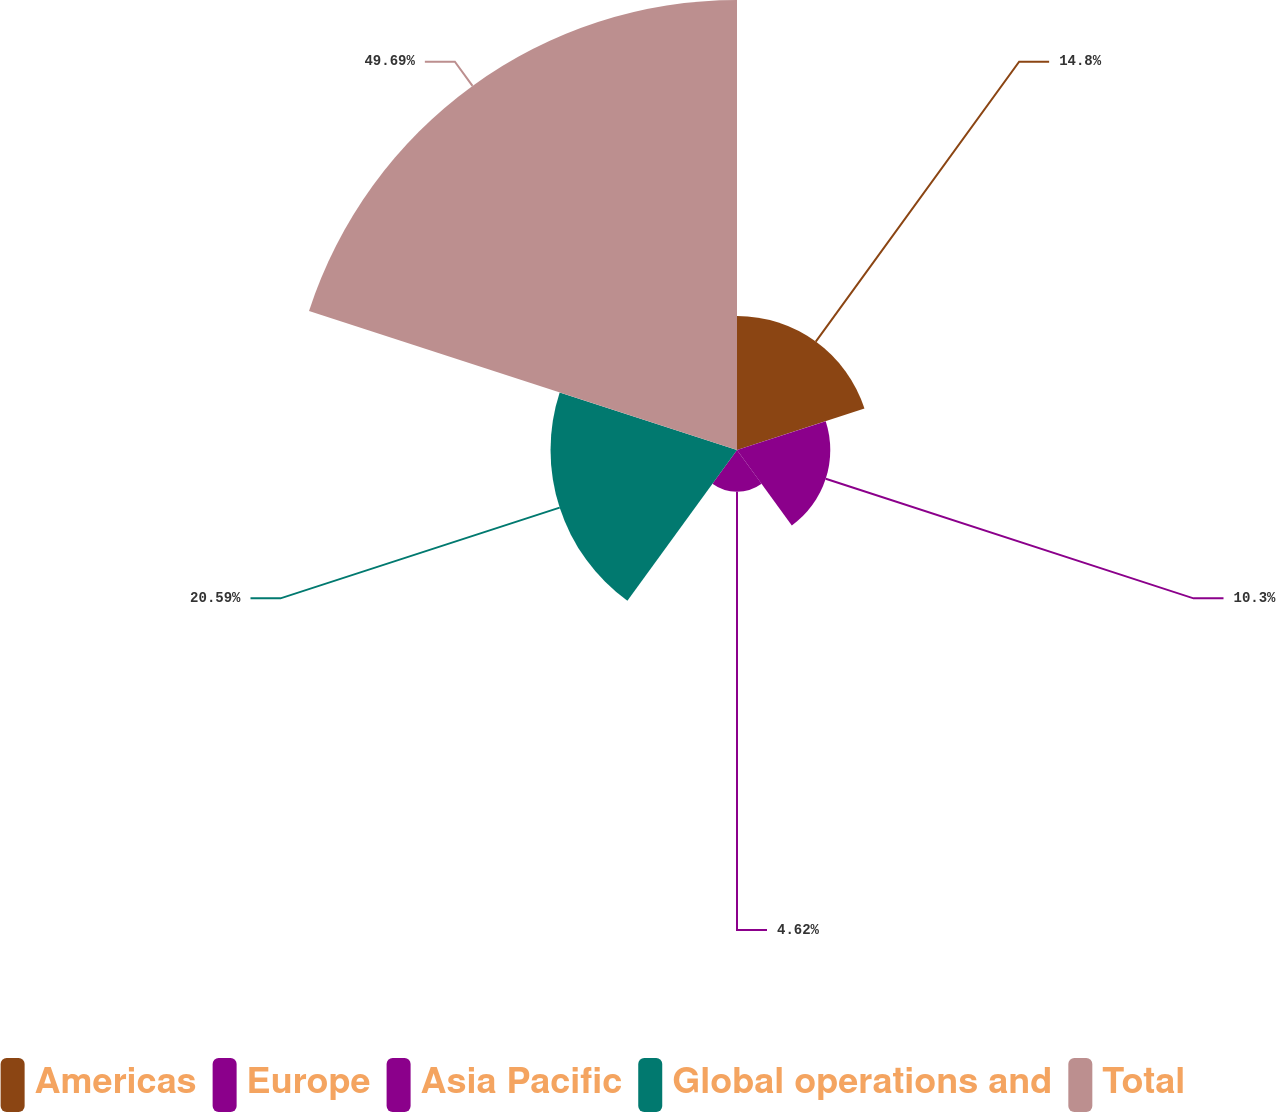Convert chart to OTSL. <chart><loc_0><loc_0><loc_500><loc_500><pie_chart><fcel>Americas<fcel>Europe<fcel>Asia Pacific<fcel>Global operations and<fcel>Total<nl><fcel>14.8%<fcel>10.3%<fcel>4.62%<fcel>20.59%<fcel>49.69%<nl></chart> 